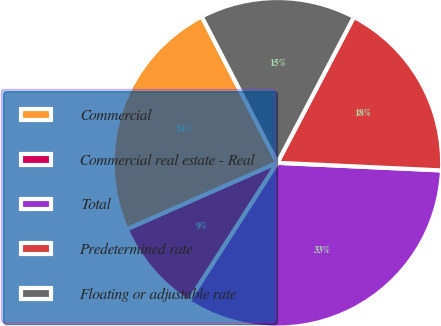Convert chart to OTSL. <chart><loc_0><loc_0><loc_500><loc_500><pie_chart><fcel>Commercial<fcel>Commercial real estate - Real<fcel>Total<fcel>Predetermined rate<fcel>Floating or adjustable rate<nl><fcel>24.03%<fcel>9.31%<fcel>33.33%<fcel>18.05%<fcel>15.29%<nl></chart> 